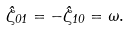Convert formula to latex. <formula><loc_0><loc_0><loc_500><loc_500>\hat { \zeta } _ { 0 1 } = - \hat { \zeta } _ { 1 0 } = \omega .</formula> 